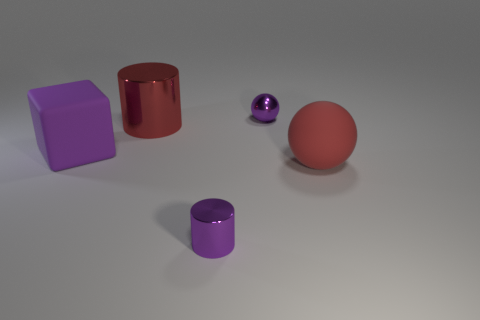What number of shiny balls have the same color as the small metal cylinder?
Offer a very short reply. 1. What size is the matte thing to the left of the tiny purple object in front of the tiny metal thing behind the purple metallic cylinder?
Your answer should be very brief. Large. What number of shiny objects are large cylinders or red objects?
Give a very brief answer. 1. There is a purple matte thing; is its shape the same as the shiny thing that is in front of the red shiny cylinder?
Provide a short and direct response. No. Are there more tiny shiny cylinders left of the purple metal cylinder than small metal things behind the purple metallic sphere?
Ensure brevity in your answer.  No. Is there any other thing that is the same color as the small shiny ball?
Ensure brevity in your answer.  Yes. There is a tiny metal thing behind the sphere in front of the big purple matte cube; is there a big purple cube behind it?
Provide a succinct answer. No. Do the metallic thing to the right of the tiny metallic cylinder and the red rubber object have the same shape?
Provide a short and direct response. Yes. Is the number of metal cylinders that are behind the big purple object less than the number of large purple rubber blocks behind the purple ball?
Offer a terse response. No. What is the material of the tiny purple cylinder?
Provide a short and direct response. Metal. 